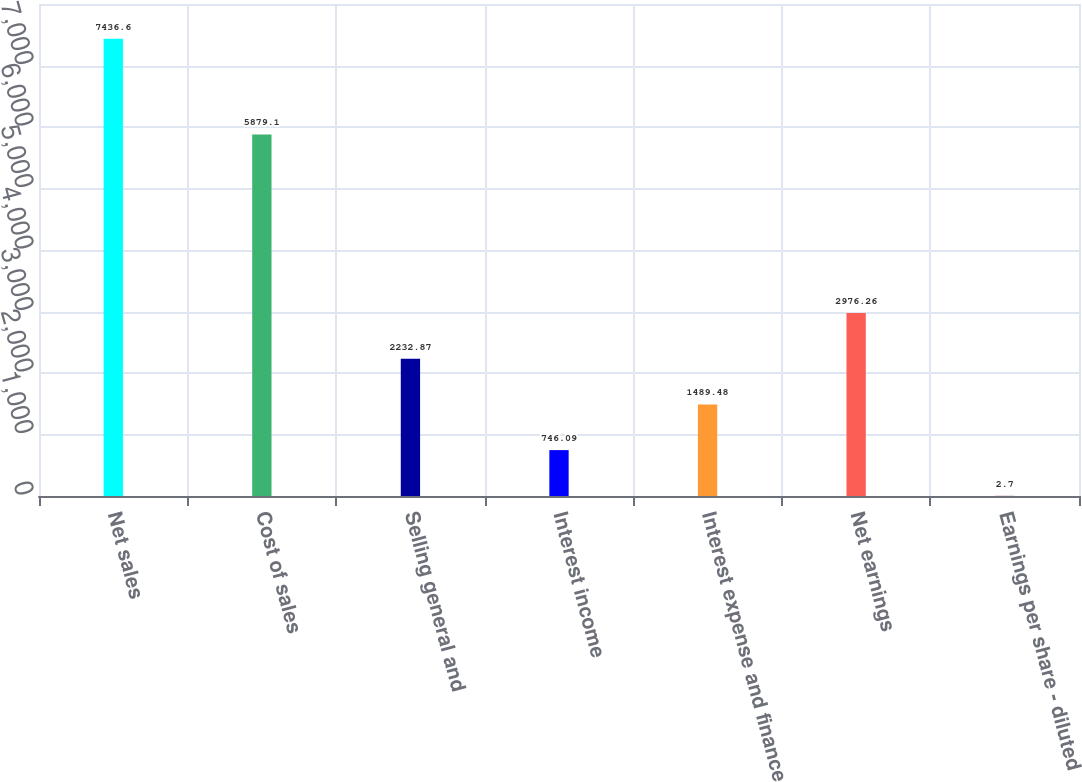Convert chart. <chart><loc_0><loc_0><loc_500><loc_500><bar_chart><fcel>Net sales<fcel>Cost of sales<fcel>Selling general and<fcel>Interest income<fcel>Interest expense and finance<fcel>Net earnings<fcel>Earnings per share - diluted<nl><fcel>7436.6<fcel>5879.1<fcel>2232.87<fcel>746.09<fcel>1489.48<fcel>2976.26<fcel>2.7<nl></chart> 